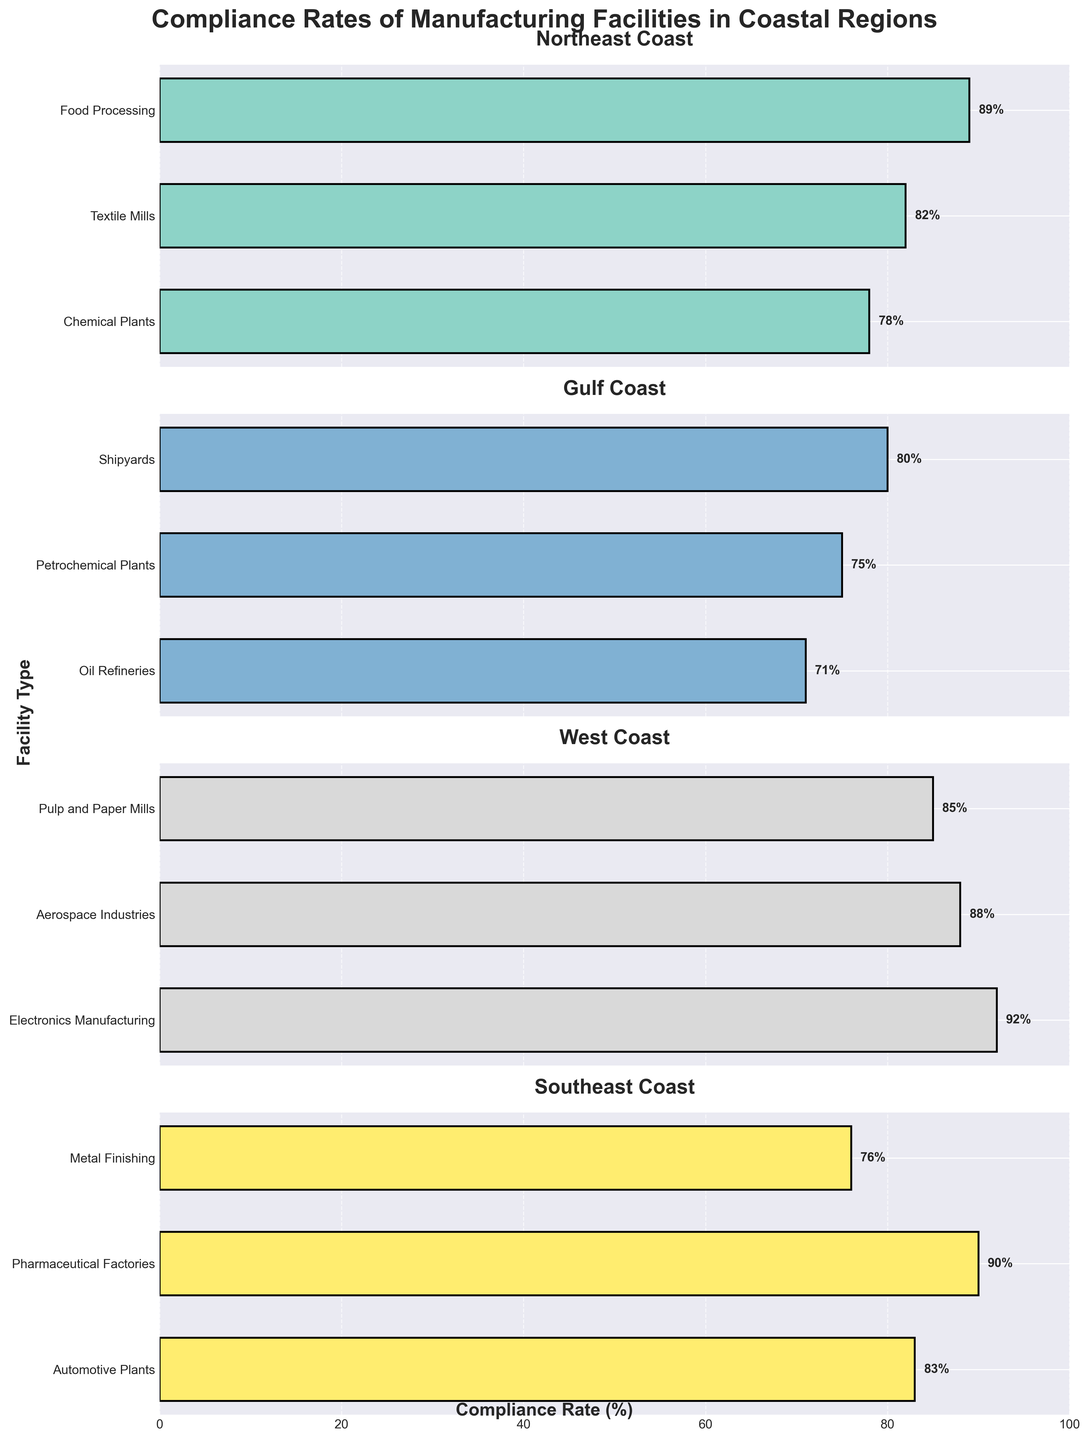What is the compliance rate for Chemical Plants in the Northeast Coast? The bar for Chemical Plants in the Northeast Coast region shows a compliance rate of 78%.
Answer: 78% Which region has the highest compliance rate in any facility type and what is the rate? The highest compliance rate is in the Electronics Manufacturing facility type in the West Coast region, which shows 92%.
Answer: West Coast, 92% How many facility types have a compliance rate above 80% in the Southeast Coast? The compliance rates above 80% in the Southeast Coast region are for Automotive Plants (83%), and Pharmaceutical Factories (90%).
Answer: 2 Which facility type has the lowest compliance rate on the Gulf Coast and what is the rate? The Oil Refineries in the Gulf Coast show the lowest compliance rate with 71% as indicated by the lowest bar in this region.
Answer: Oil Refineries, 71% What is the range of compliance rates for the Northeast Coast region? The highest compliance rate in the Northeast Coast is 89% for Food Processing, and the lowest is 78% for Chemical Plants. The range is therefore 89% - 78% = 11%.
Answer: 11% Between the West Coast and Southeast Coast, which region has more facility types with compliance rates above 85%? The West Coast has Electronics Manufacturing (92%), Aerospace Industries (88%), and Pulp and Paper Mills (85%) which makes 3 facility types, while the Southeast Coast has only Pharmaceutical Factories (90%).
Answer: West Coast What is the average compliance rate for all facility types on the Gulf Coast? The compliance rates for the Gulf Coast are Oil Refineries (71%), Petrochemical Plants (75%), and Shipyards (80%). The average is calculated as (71 + 75 + 80) / 3 ≈ 75.33%.
Answer: 75.33% Which region has the most uniform compliance rates (smallest range) across its facility types? Calculating the ranges:
- Northeast Coast: 89% - 78% = 11%
- Gulf Coast: 80% - 71% = 9%
- West Coast: 92% - 85% = 7%
- Southeast Coast: 90% - 76% = 14%
The West Coast has the smallest range of 7%.
Answer: West Coast How many regions have at least one facility type with a compliance rate above 85%? Calculating per region:
- Northeast Coast: 1 facility (Food Processing, 89%)
- Gulf Coast: 0 facilities
- West Coast: 3 facilities (Electronics Manufacturing, 92%; Aerospace Industries, 88%; Pulp and Paper Mills, 85%)
- Southeast Coast: 1 facility (Pharmaceutical Factories, 90%)
Thus, three regions have at least one facility type above 85%.
Answer: 3 